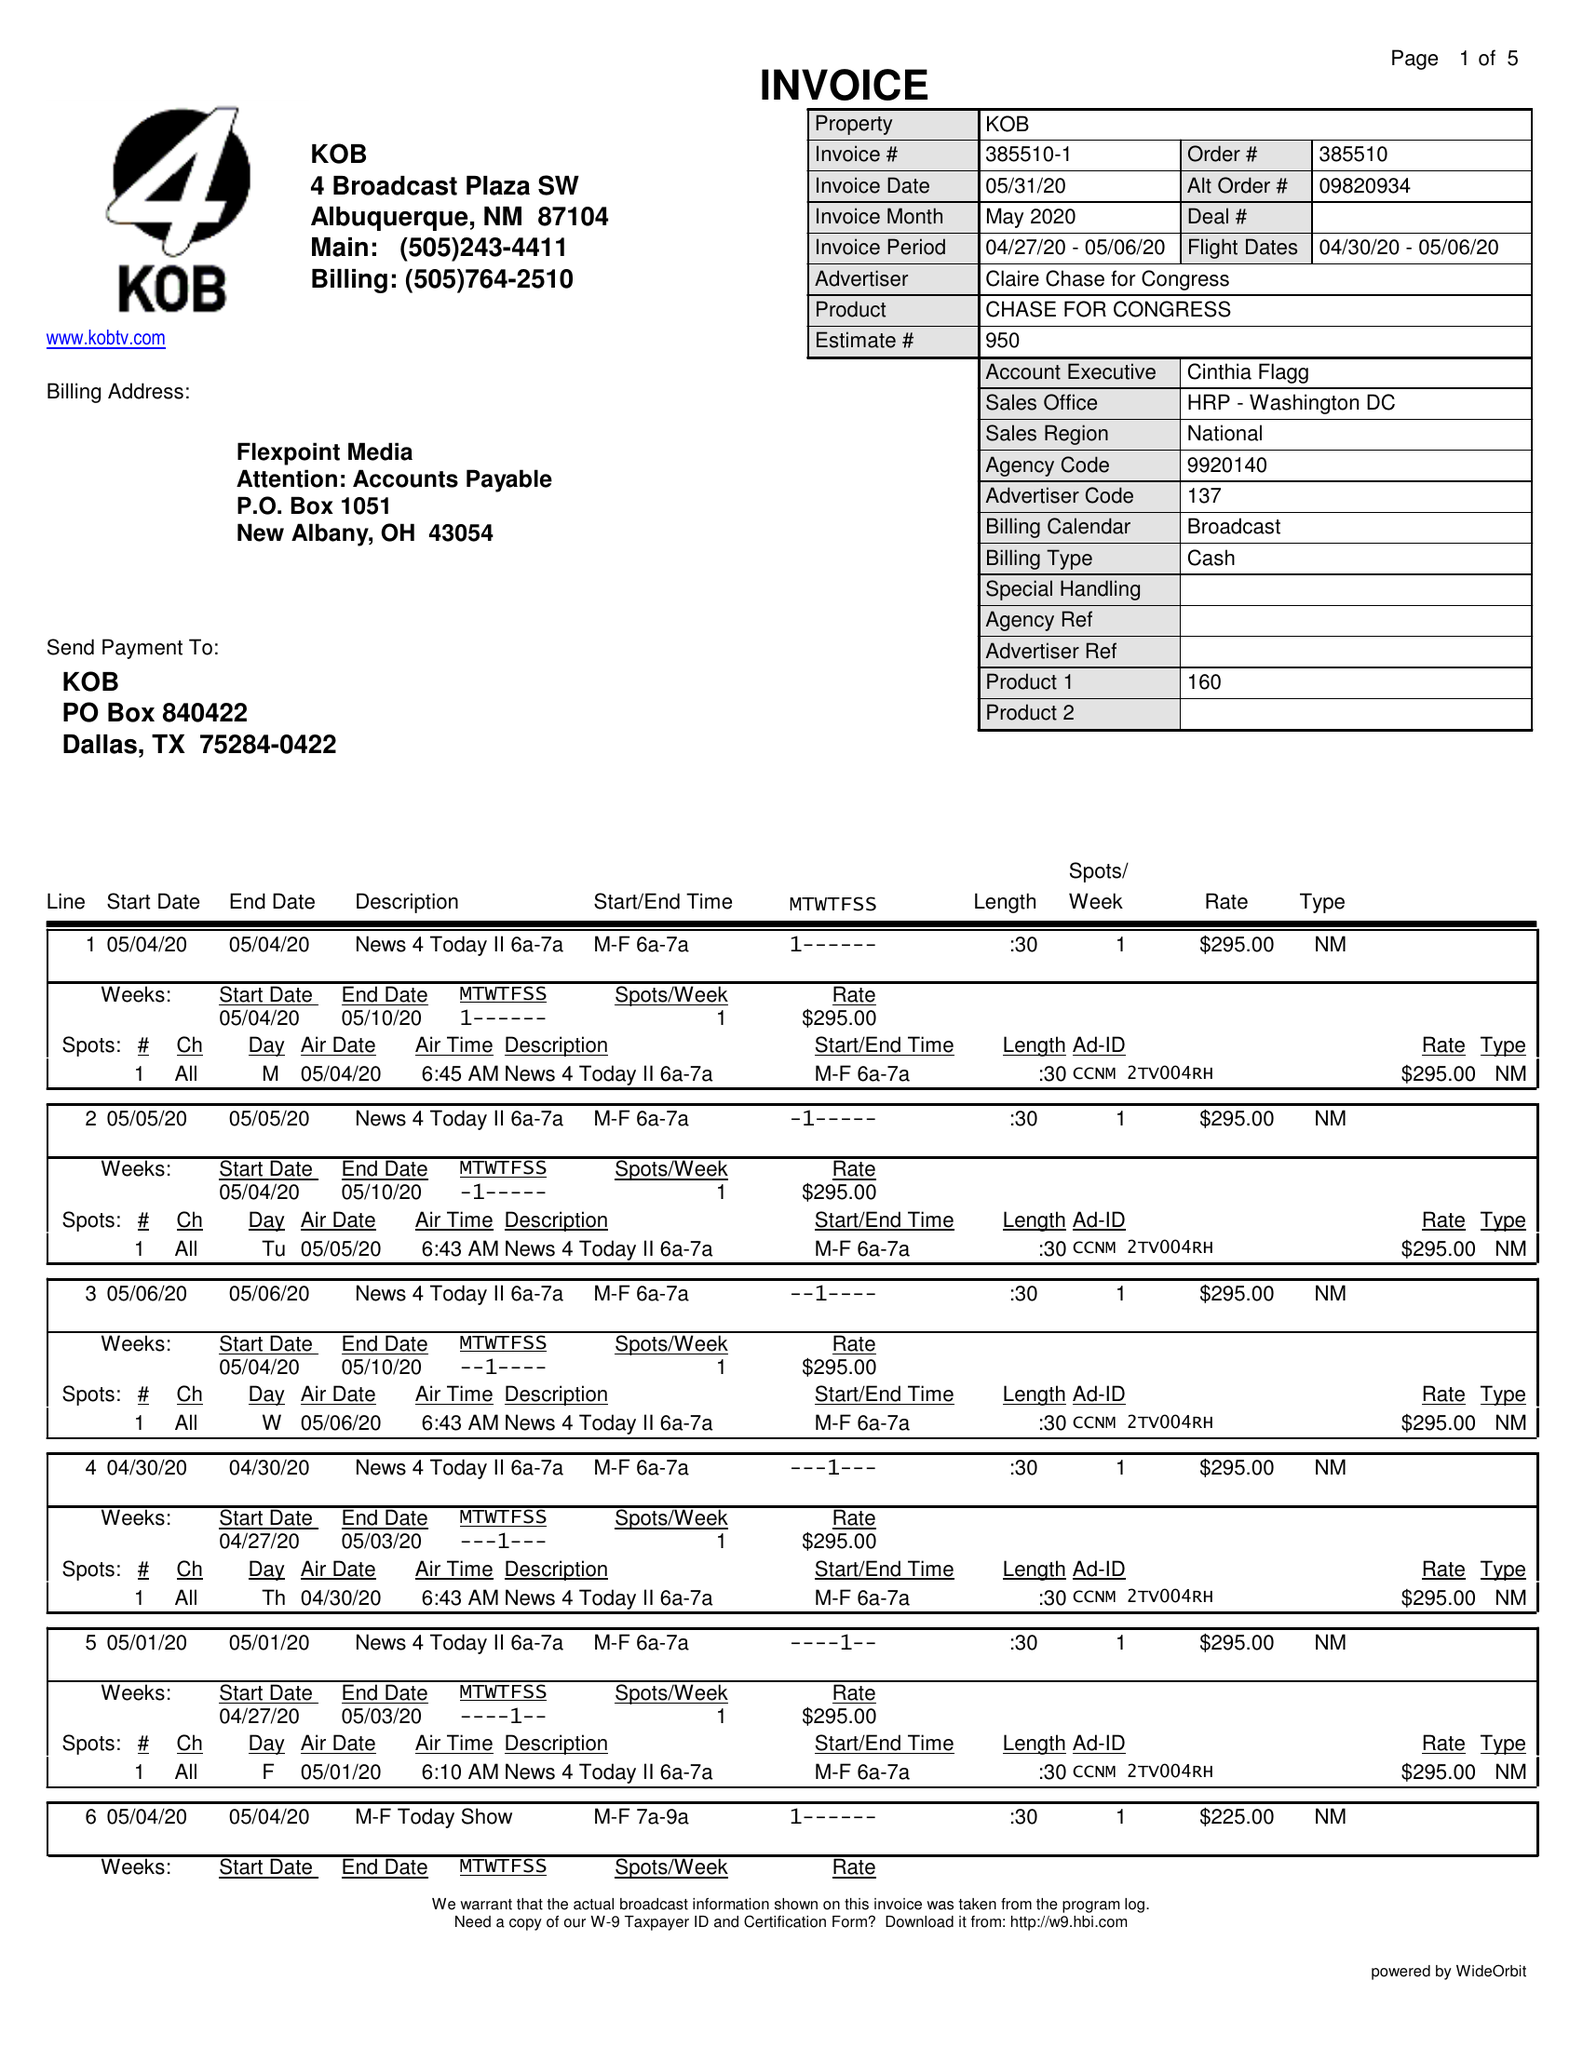What is the value for the contract_num?
Answer the question using a single word or phrase. 385510 